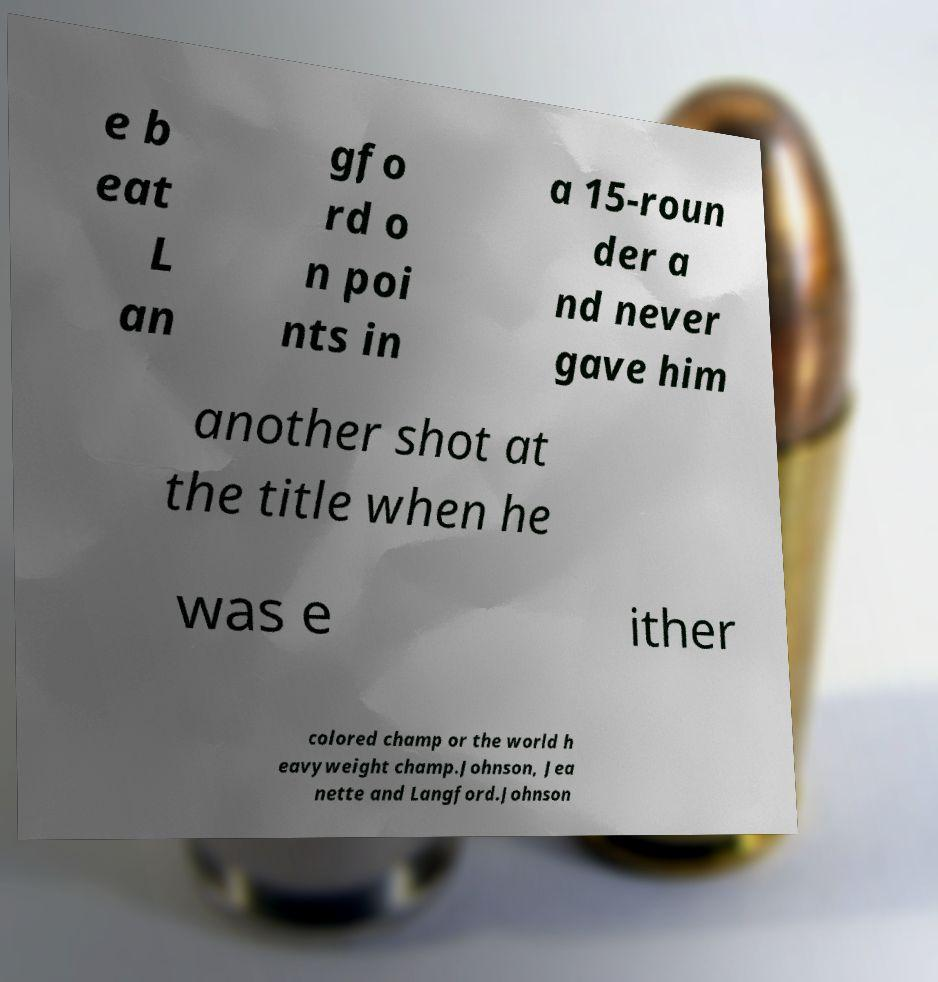Could you assist in decoding the text presented in this image and type it out clearly? e b eat L an gfo rd o n poi nts in a 15-roun der a nd never gave him another shot at the title when he was e ither colored champ or the world h eavyweight champ.Johnson, Jea nette and Langford.Johnson 